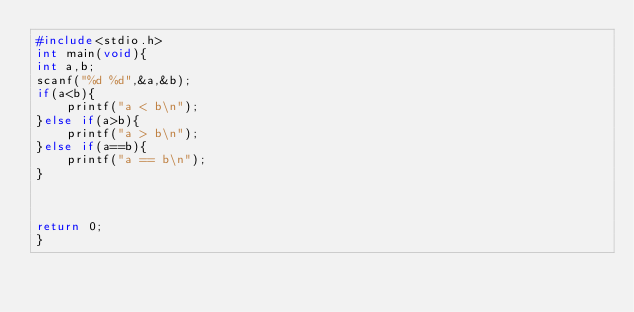Convert code to text. <code><loc_0><loc_0><loc_500><loc_500><_C_>#include<stdio.h>
int main(void){
int a,b;
scanf("%d %d",&a,&b);
if(a<b){
    printf("a < b\n");
}else if(a>b){
    printf("a > b\n");
}else if(a==b){
    printf("a == b\n");
}



return 0;
}</code> 